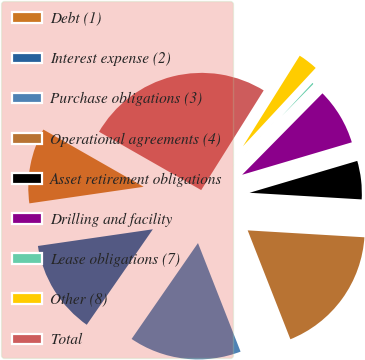<chart> <loc_0><loc_0><loc_500><loc_500><pie_chart><fcel>Debt (1)<fcel>Interest expense (2)<fcel>Purchase obligations (3)<fcel>Operational agreements (4)<fcel>Asset retirement obligations<fcel>Drilling and facility<fcel>Lease obligations (7)<fcel>Other (8)<fcel>Total<nl><fcel>10.55%<fcel>13.07%<fcel>15.59%<fcel>18.11%<fcel>5.52%<fcel>8.03%<fcel>0.48%<fcel>3.0%<fcel>25.66%<nl></chart> 